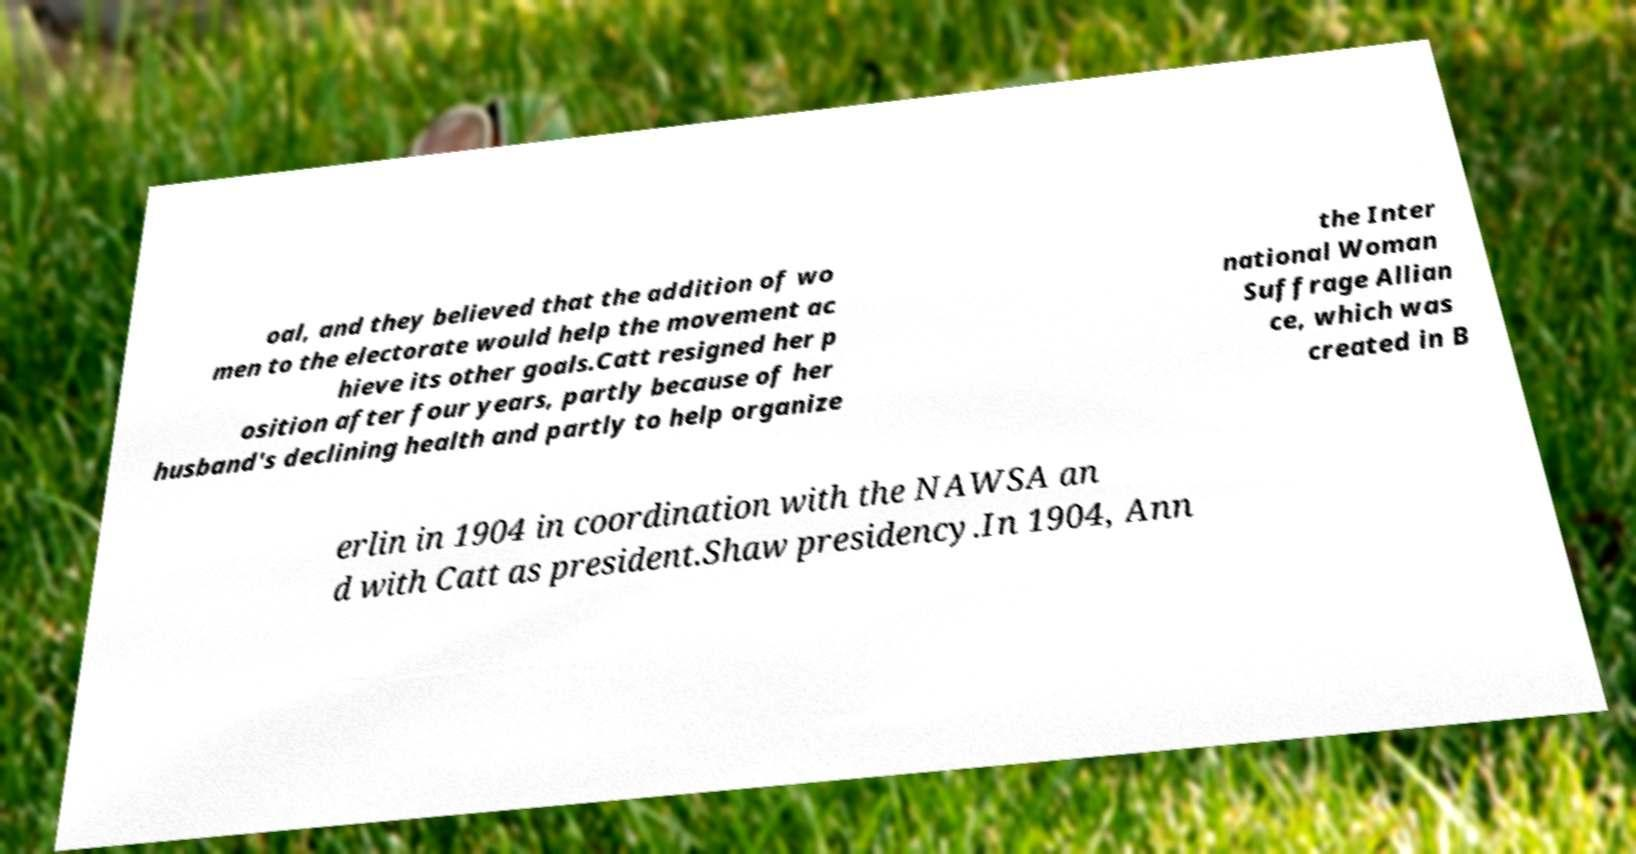Can you accurately transcribe the text from the provided image for me? oal, and they believed that the addition of wo men to the electorate would help the movement ac hieve its other goals.Catt resigned her p osition after four years, partly because of her husband's declining health and partly to help organize the Inter national Woman Suffrage Allian ce, which was created in B erlin in 1904 in coordination with the NAWSA an d with Catt as president.Shaw presidency.In 1904, Ann 